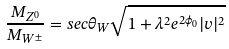Convert formula to latex. <formula><loc_0><loc_0><loc_500><loc_500>\frac { M _ { Z ^ { 0 } } } { M _ { W ^ { \pm } } } = s e c \theta _ { W } \sqrt { 1 + \lambda ^ { 2 } e ^ { 2 \phi _ { 0 } } | v | ^ { 2 } }</formula> 